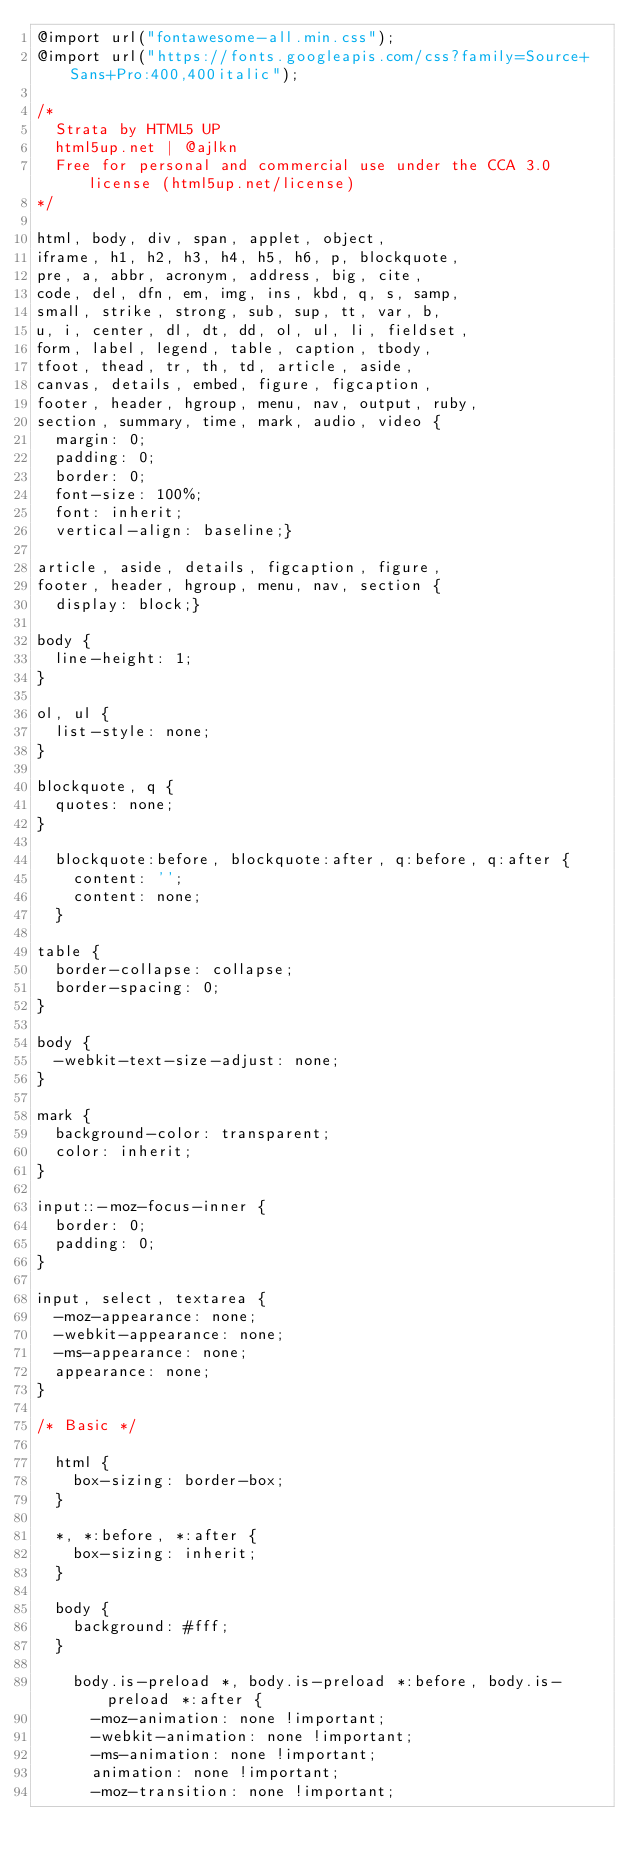Convert code to text. <code><loc_0><loc_0><loc_500><loc_500><_CSS_>@import url("fontawesome-all.min.css");
@import url("https://fonts.googleapis.com/css?family=Source+Sans+Pro:400,400italic");

/*
	Strata by HTML5 UP
	html5up.net | @ajlkn
	Free for personal and commercial use under the CCA 3.0 license (html5up.net/license)
*/

html, body, div, span, applet, object,
iframe, h1, h2, h3, h4, h5, h6, p, blockquote,
pre, a, abbr, acronym, address, big, cite,
code, del, dfn, em, img, ins, kbd, q, s, samp,
small, strike, strong, sub, sup, tt, var, b,
u, i, center, dl, dt, dd, ol, ul, li, fieldset,
form, label, legend, table, caption, tbody,
tfoot, thead, tr, th, td, article, aside,
canvas, details, embed, figure, figcaption,
footer, header, hgroup, menu, nav, output, ruby,
section, summary, time, mark, audio, video {
	margin: 0;
	padding: 0;
	border: 0;
	font-size: 100%;
	font: inherit;
	vertical-align: baseline;}

article, aside, details, figcaption, figure,
footer, header, hgroup, menu, nav, section {
	display: block;}

body {
	line-height: 1;
}

ol, ul {
	list-style: none;
}

blockquote, q {
	quotes: none;
}

	blockquote:before, blockquote:after, q:before, q:after {
		content: '';
		content: none;
	}

table {
	border-collapse: collapse;
	border-spacing: 0;
}

body {
	-webkit-text-size-adjust: none;
}

mark {
	background-color: transparent;
	color: inherit;
}

input::-moz-focus-inner {
	border: 0;
	padding: 0;
}

input, select, textarea {
	-moz-appearance: none;
	-webkit-appearance: none;
	-ms-appearance: none;
	appearance: none;
}

/* Basic */

	html {
		box-sizing: border-box;
	}

	*, *:before, *:after {
		box-sizing: inherit;
	}

	body {
		background: #fff;
	}

		body.is-preload *, body.is-preload *:before, body.is-preload *:after {
			-moz-animation: none !important;
			-webkit-animation: none !important;
			-ms-animation: none !important;
			animation: none !important;
			-moz-transition: none !important;</code> 